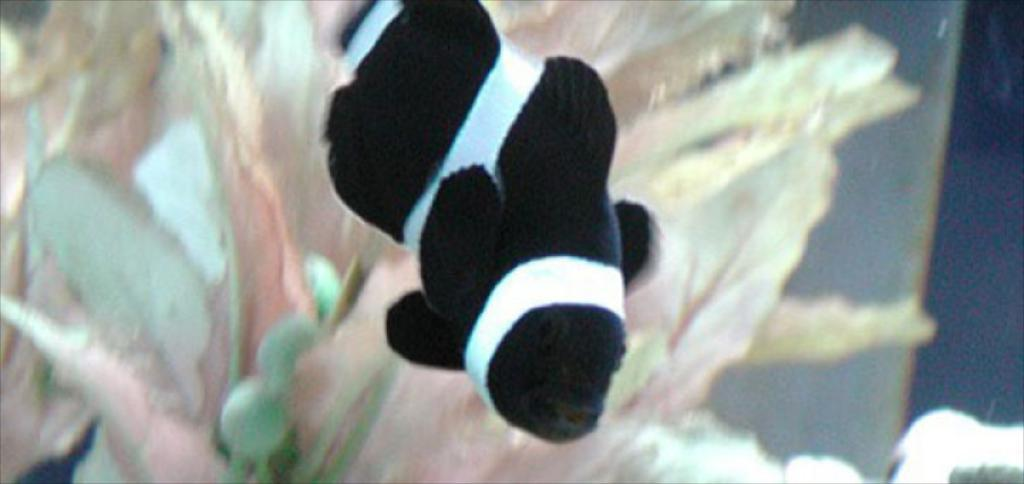What is the main subject of the image? The main subject of the image is a fish swimming. What features can be observed on the fish? The fish has fins, a mouth, a nose, and eyes. What is present in the background of the image? There is an aquatic plant in the backdrop of the image. How many bombs can be seen in the image? There are no bombs present in the image; it features a fish swimming with an aquatic plant in the background. What type of poison is the fish using to swim in the image? There is no poison involved in the fish swimming in the image; it is a natural activity for fish. 